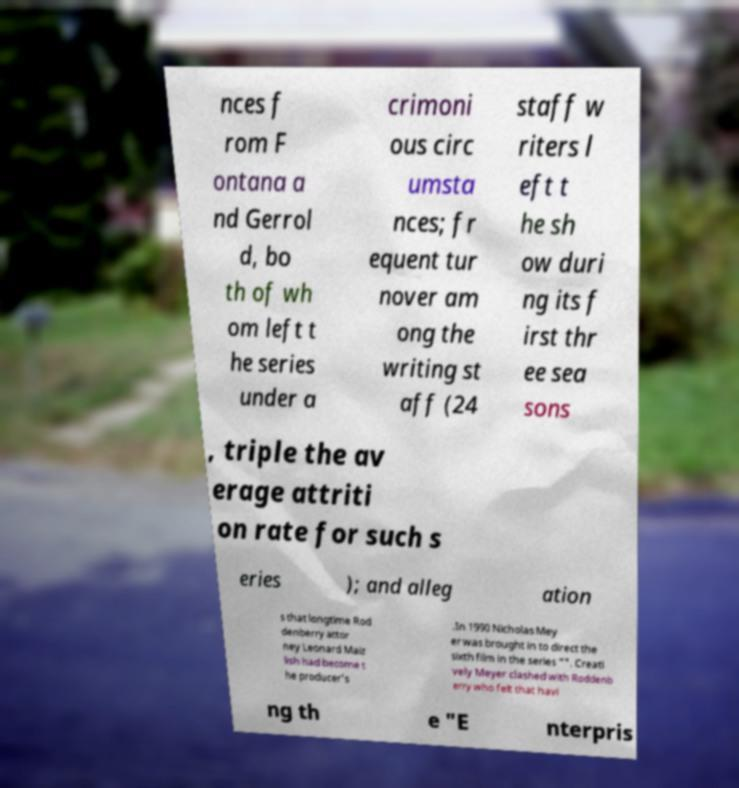Can you accurately transcribe the text from the provided image for me? nces f rom F ontana a nd Gerrol d, bo th of wh om left t he series under a crimoni ous circ umsta nces; fr equent tur nover am ong the writing st aff (24 staff w riters l eft t he sh ow duri ng its f irst thr ee sea sons , triple the av erage attriti on rate for such s eries ); and alleg ation s that longtime Rod denberry attor ney Leonard Maiz lish had become t he producer's .In 1990 Nicholas Mey er was brought in to direct the sixth film in the series "". Creati vely Meyer clashed with Roddenb erry who felt that havi ng th e "E nterpris 